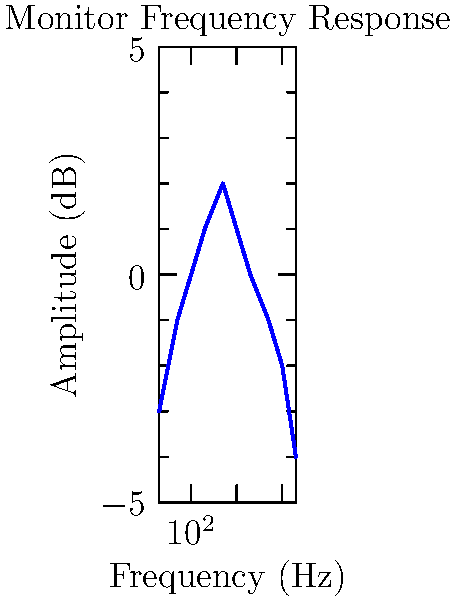As a music teacher emphasizing technical skills in audio recording, analyze the frequency response graph of a studio monitor shown above. Which frequency range exhibits the most significant boost, and how might this affect the accuracy of mix decisions? To answer this question, let's analyze the frequency response graph step-by-step:

1. The x-axis represents frequency in Hz, ranging from 20 Hz to 20 kHz (the audible spectrum).
2. The y-axis represents amplitude in dB, ranging from -5 dB to +5 dB.
3. Examine the curve to identify the highest point:
   - The peak occurs around 500 Hz, with approximately +2 dB boost.
4. Compare this to other frequency ranges:
   - Low frequencies (below 100 Hz) show a slight dip.
   - Mid-high frequencies (1 kHz to 5 kHz) are relatively flat.
   - High frequencies (above 5 kHz) show a gradual roll-off.
5. The most significant boost is in the 200-1000 Hz range, peaking at 500 Hz.
6. Impact on mix decisions:
   - This boost will emphasize frequencies in the lower midrange.
   - Instruments like guitars, vocals, and snare drums might sound more prominent.
   - Mix engineers might compensate by reducing these frequencies, potentially leading to thin-sounding mixes on other systems.

The 500 Hz boost could cause overcompensation in mix decisions, potentially resulting in an unbalanced final product when played on other audio systems.
Answer: 500 Hz range; may lead to underemphasized lower midrange in mixes 